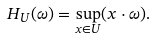<formula> <loc_0><loc_0><loc_500><loc_500>H _ { U } ( \omega ) = \sup _ { x \in U } ( x \cdot \omega ) .</formula> 